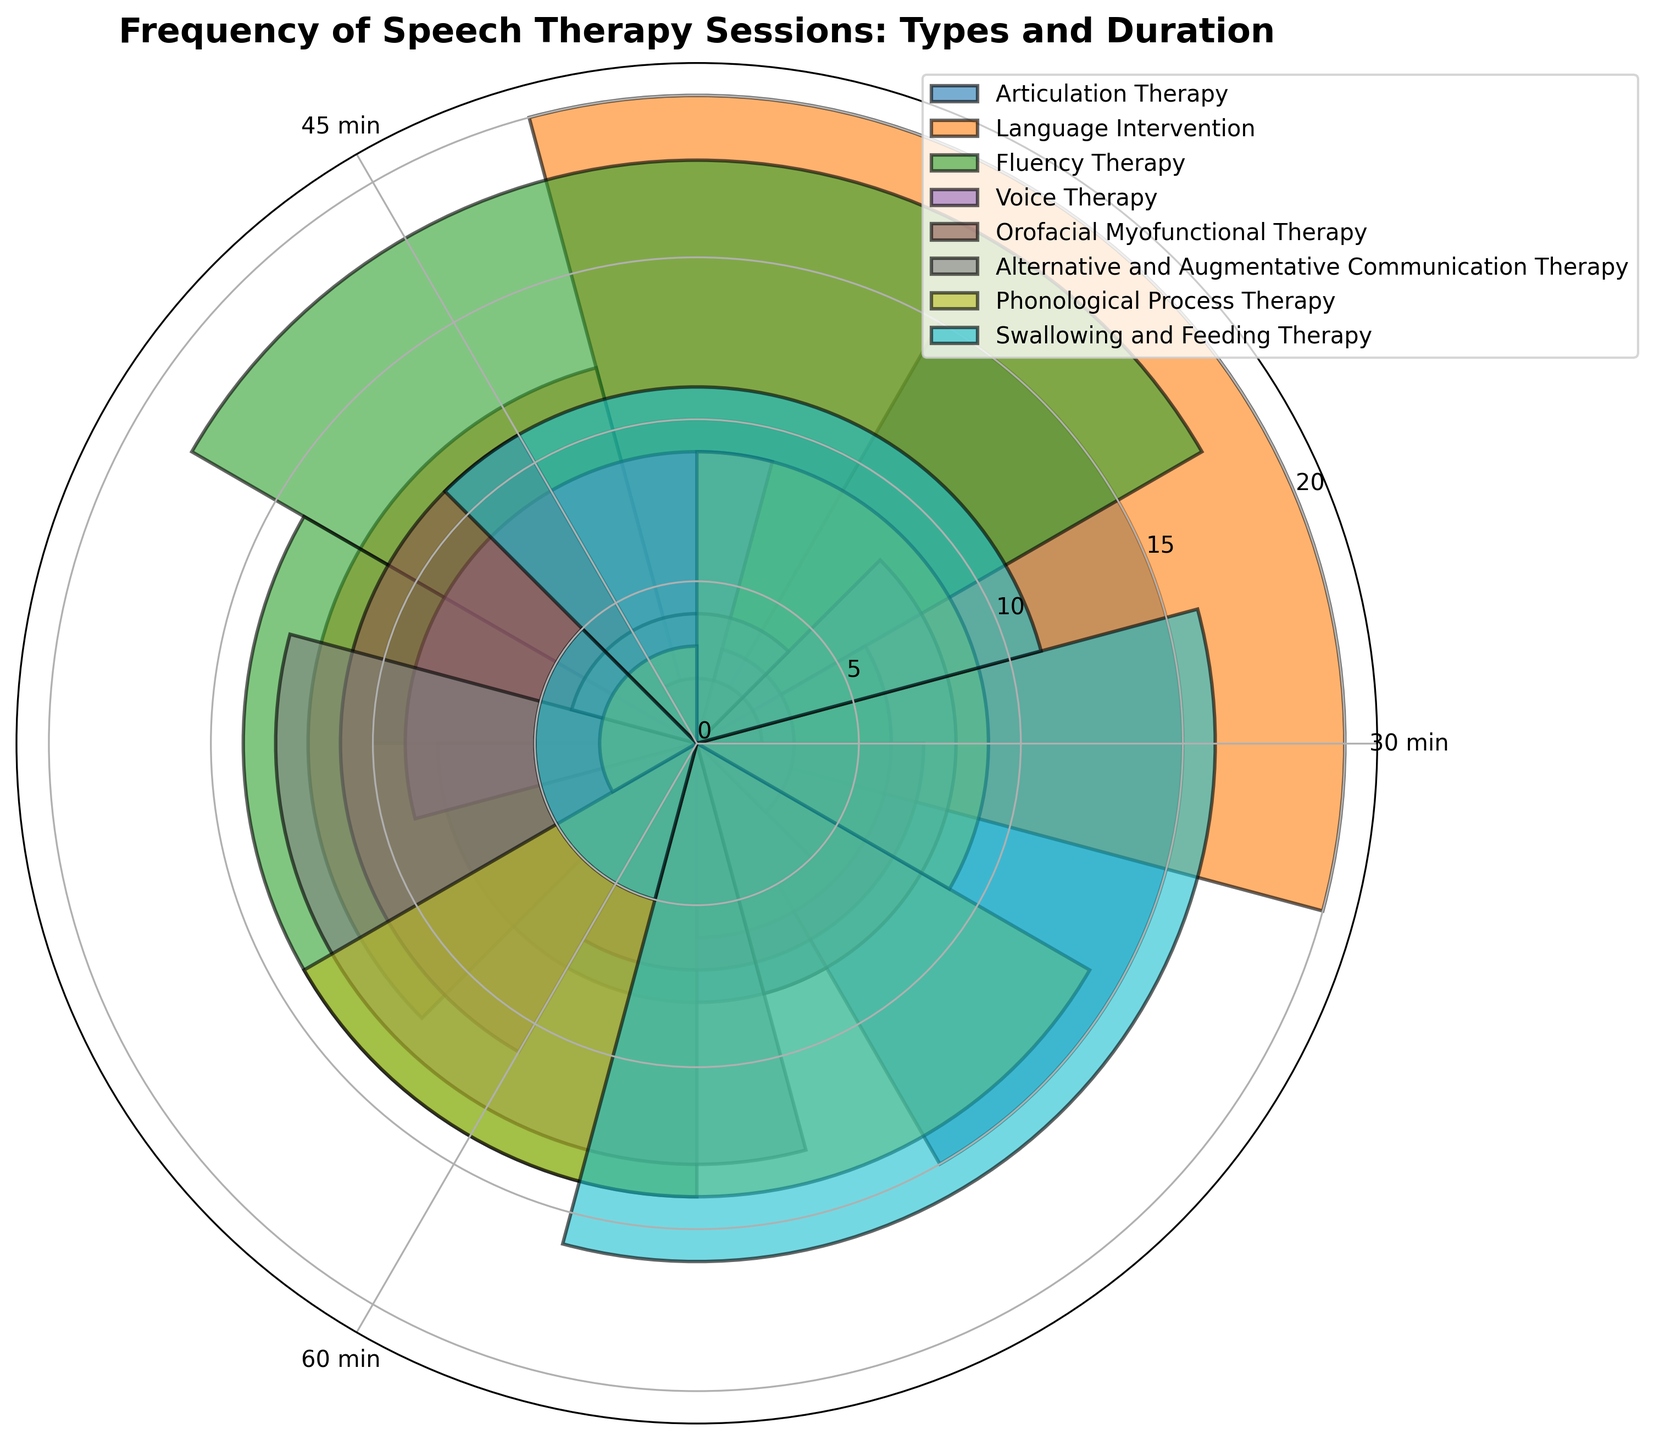Which type of therapy has the highest frequency for 30-minute sessions? Look at the bars corresponding to 30-minute durations. The tallest bar is associated with Language Intervention, which indicates the highest frequency.
Answer: Language Intervention What is the total frequency of all 45-minute Articulation Therapy sessions? Find the frequency values for 45-minute Articulation Therapy sessions. Add them up: 10.
Answer: 10 Which type of therapy is represented by the green bars? Use the legend to identify the therapy type associated with the green color.
Answer: Fluency Therapy Is the frequency of 60-minute sessions for Voice Therapy greater than that for Alternative and Augmentative Communication Therapy? Compare the heights of the bars corresponding to 60-minute durations for Voice Therapy and Alternative and Augmentative Communication Therapy. Voice Therapy has a frequency of 3, which is less than AAC Therapy's 4.
Answer: No What's the average frequency of 30-minute sessions across all therapy types? Add the frequencies of all 30-minute sessions across all types: (15+20+18+9+11+13+14+16). Divide the sum by 8 (the number of therapy types): (15+20+18+9+11+13+14+16)/8 = 14.5.
Answer: 14.5 What is the difference in frequency between the 30-minute sessions of Swallowing and Feeding Therapy and Phonological Process Therapy? Subtract the frequency of 30-minute Phonological Process Therapy sessions (14) from that of Swallowing and Feeding Therapy sessions (16): 16 - 14 = 2.
Answer: 2 Which type of therapy has the lowest frequency for 60-minute sessions? Look at the bars corresponding to 60-minute durations. The shortest bar is associated with Orofacial Myofunctional Therapy, which indicates the lowest frequency.
Answer: Orofacial Myofunctional Therapy Are there more 30-minute or 45-minute sessions for Fluency Therapy? Compare the heights of the bars corresponding to 30-minute and 45-minute durations for Fluency Therapy. The 30-minute session bar is taller (frequency 18) than the 45-minute session bar (frequency 14).
Answer: 30-minute What's the range of frequencies for 45-minute Language Intervention sessions? Identify the maximum and minimum frequencies for 45-minute Language Intervention sessions. The frequency is 12 for these sessions, so the range is 0.
Answer: 0 What's the sum of frequencies for all Alternative and Augmentative Communication Therapy sessions? Add up the frequencies for all durations of Alternative and Augmentative Communication Therapy: 13 (30-min) + 8 (45-min) + 4 (60-min) = 25.
Answer: 25 